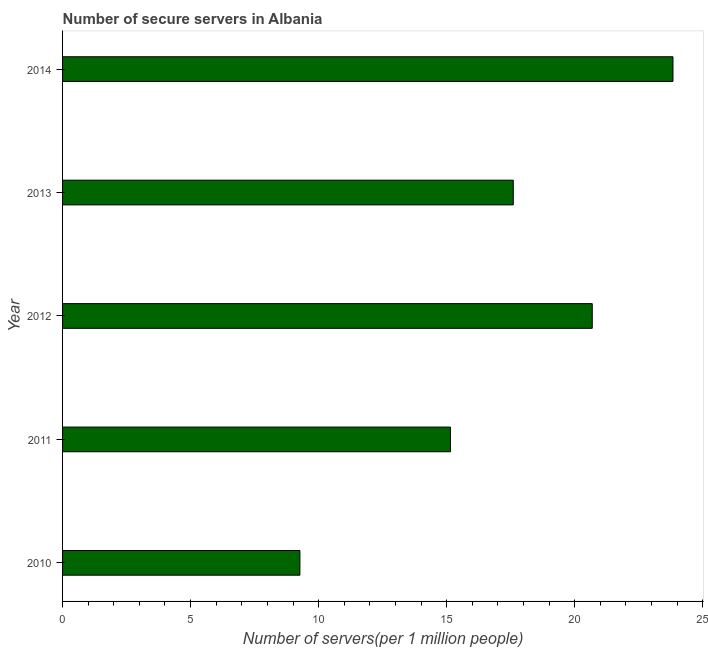Does the graph contain any zero values?
Offer a very short reply. No. Does the graph contain grids?
Ensure brevity in your answer.  No. What is the title of the graph?
Your answer should be very brief. Number of secure servers in Albania. What is the label or title of the X-axis?
Ensure brevity in your answer.  Number of servers(per 1 million people). What is the number of secure internet servers in 2010?
Your response must be concise. 9.27. Across all years, what is the maximum number of secure internet servers?
Ensure brevity in your answer.  23.84. Across all years, what is the minimum number of secure internet servers?
Offer a terse response. 9.27. In which year was the number of secure internet servers minimum?
Provide a succinct answer. 2010. What is the sum of the number of secure internet servers?
Ensure brevity in your answer.  86.54. What is the difference between the number of secure internet servers in 2011 and 2014?
Your answer should be very brief. -8.69. What is the average number of secure internet servers per year?
Ensure brevity in your answer.  17.31. What is the median number of secure internet servers?
Give a very brief answer. 17.6. Do a majority of the years between 2013 and 2012 (inclusive) have number of secure internet servers greater than 21 ?
Give a very brief answer. No. What is the ratio of the number of secure internet servers in 2013 to that in 2014?
Keep it short and to the point. 0.74. Is the difference between the number of secure internet servers in 2012 and 2013 greater than the difference between any two years?
Your response must be concise. No. What is the difference between the highest and the second highest number of secure internet servers?
Keep it short and to the point. 3.15. Is the sum of the number of secure internet servers in 2011 and 2012 greater than the maximum number of secure internet servers across all years?
Keep it short and to the point. Yes. What is the difference between the highest and the lowest number of secure internet servers?
Keep it short and to the point. 14.57. In how many years, is the number of secure internet servers greater than the average number of secure internet servers taken over all years?
Your response must be concise. 3. How many years are there in the graph?
Make the answer very short. 5. Are the values on the major ticks of X-axis written in scientific E-notation?
Your answer should be compact. No. What is the Number of servers(per 1 million people) of 2010?
Make the answer very short. 9.27. What is the Number of servers(per 1 million people) of 2011?
Provide a short and direct response. 15.15. What is the Number of servers(per 1 million people) of 2012?
Make the answer very short. 20.69. What is the Number of servers(per 1 million people) of 2013?
Provide a short and direct response. 17.6. What is the Number of servers(per 1 million people) in 2014?
Your answer should be very brief. 23.84. What is the difference between the Number of servers(per 1 million people) in 2010 and 2011?
Give a very brief answer. -5.88. What is the difference between the Number of servers(per 1 million people) in 2010 and 2012?
Your answer should be very brief. -11.42. What is the difference between the Number of servers(per 1 million people) in 2010 and 2013?
Keep it short and to the point. -8.33. What is the difference between the Number of servers(per 1 million people) in 2010 and 2014?
Your response must be concise. -14.57. What is the difference between the Number of servers(per 1 million people) in 2011 and 2012?
Your answer should be very brief. -5.54. What is the difference between the Number of servers(per 1 million people) in 2011 and 2013?
Make the answer very short. -2.45. What is the difference between the Number of servers(per 1 million people) in 2011 and 2014?
Ensure brevity in your answer.  -8.69. What is the difference between the Number of servers(per 1 million people) in 2012 and 2013?
Offer a terse response. 3.08. What is the difference between the Number of servers(per 1 million people) in 2012 and 2014?
Provide a short and direct response. -3.15. What is the difference between the Number of servers(per 1 million people) in 2013 and 2014?
Your answer should be compact. -6.24. What is the ratio of the Number of servers(per 1 million people) in 2010 to that in 2011?
Provide a short and direct response. 0.61. What is the ratio of the Number of servers(per 1 million people) in 2010 to that in 2012?
Keep it short and to the point. 0.45. What is the ratio of the Number of servers(per 1 million people) in 2010 to that in 2013?
Keep it short and to the point. 0.53. What is the ratio of the Number of servers(per 1 million people) in 2010 to that in 2014?
Ensure brevity in your answer.  0.39. What is the ratio of the Number of servers(per 1 million people) in 2011 to that in 2012?
Your answer should be very brief. 0.73. What is the ratio of the Number of servers(per 1 million people) in 2011 to that in 2013?
Offer a very short reply. 0.86. What is the ratio of the Number of servers(per 1 million people) in 2011 to that in 2014?
Ensure brevity in your answer.  0.64. What is the ratio of the Number of servers(per 1 million people) in 2012 to that in 2013?
Offer a terse response. 1.18. What is the ratio of the Number of servers(per 1 million people) in 2012 to that in 2014?
Your response must be concise. 0.87. What is the ratio of the Number of servers(per 1 million people) in 2013 to that in 2014?
Give a very brief answer. 0.74. 